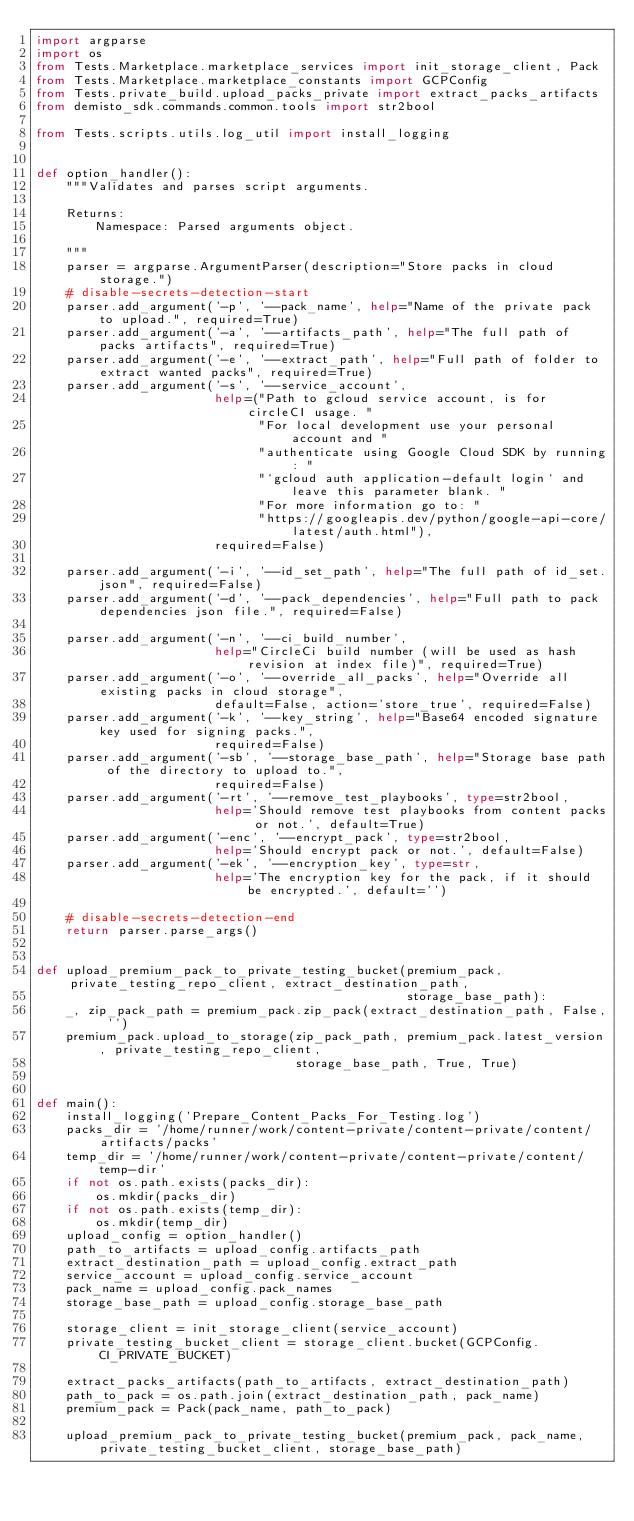Convert code to text. <code><loc_0><loc_0><loc_500><loc_500><_Python_>import argparse
import os
from Tests.Marketplace.marketplace_services import init_storage_client, Pack
from Tests.Marketplace.marketplace_constants import GCPConfig
from Tests.private_build.upload_packs_private import extract_packs_artifacts
from demisto_sdk.commands.common.tools import str2bool

from Tests.scripts.utils.log_util import install_logging


def option_handler():
    """Validates and parses script arguments.

    Returns:
        Namespace: Parsed arguments object.

    """
    parser = argparse.ArgumentParser(description="Store packs in cloud storage.")
    # disable-secrets-detection-start
    parser.add_argument('-p', '--pack_name', help="Name of the private pack to upload.", required=True)
    parser.add_argument('-a', '--artifacts_path', help="The full path of packs artifacts", required=True)
    parser.add_argument('-e', '--extract_path', help="Full path of folder to extract wanted packs", required=True)
    parser.add_argument('-s', '--service_account',
                        help=("Path to gcloud service account, is for circleCI usage. "
                              "For local development use your personal account and "
                              "authenticate using Google Cloud SDK by running: "
                              "`gcloud auth application-default login` and leave this parameter blank. "
                              "For more information go to: "
                              "https://googleapis.dev/python/google-api-core/latest/auth.html"),
                        required=False)

    parser.add_argument('-i', '--id_set_path', help="The full path of id_set.json", required=False)
    parser.add_argument('-d', '--pack_dependencies', help="Full path to pack dependencies json file.", required=False)

    parser.add_argument('-n', '--ci_build_number',
                        help="CircleCi build number (will be used as hash revision at index file)", required=True)
    parser.add_argument('-o', '--override_all_packs', help="Override all existing packs in cloud storage",
                        default=False, action='store_true', required=False)
    parser.add_argument('-k', '--key_string', help="Base64 encoded signature key used for signing packs.",
                        required=False)
    parser.add_argument('-sb', '--storage_base_path', help="Storage base path of the directory to upload to.",
                        required=False)
    parser.add_argument('-rt', '--remove_test_playbooks', type=str2bool,
                        help='Should remove test playbooks from content packs or not.', default=True)
    parser.add_argument('-enc', '--encrypt_pack', type=str2bool,
                        help='Should encrypt pack or not.', default=False)
    parser.add_argument('-ek', '--encryption_key', type=str,
                        help='The encryption key for the pack, if it should be encrypted.', default='')

    # disable-secrets-detection-end
    return parser.parse_args()


def upload_premium_pack_to_private_testing_bucket(premium_pack, private_testing_repo_client, extract_destination_path,
                                                  storage_base_path):
    _, zip_pack_path = premium_pack.zip_pack(extract_destination_path, False, '')
    premium_pack.upload_to_storage(zip_pack_path, premium_pack.latest_version, private_testing_repo_client,
                                   storage_base_path, True, True)


def main():
    install_logging('Prepare_Content_Packs_For_Testing.log')
    packs_dir = '/home/runner/work/content-private/content-private/content/artifacts/packs'
    temp_dir = '/home/runner/work/content-private/content-private/content/temp-dir'
    if not os.path.exists(packs_dir):
        os.mkdir(packs_dir)
    if not os.path.exists(temp_dir):
        os.mkdir(temp_dir)
    upload_config = option_handler()
    path_to_artifacts = upload_config.artifacts_path
    extract_destination_path = upload_config.extract_path
    service_account = upload_config.service_account
    pack_name = upload_config.pack_names
    storage_base_path = upload_config.storage_base_path

    storage_client = init_storage_client(service_account)
    private_testing_bucket_client = storage_client.bucket(GCPConfig.CI_PRIVATE_BUCKET)

    extract_packs_artifacts(path_to_artifacts, extract_destination_path)
    path_to_pack = os.path.join(extract_destination_path, pack_name)
    premium_pack = Pack(pack_name, path_to_pack)

    upload_premium_pack_to_private_testing_bucket(premium_pack, pack_name, private_testing_bucket_client, storage_base_path)
</code> 